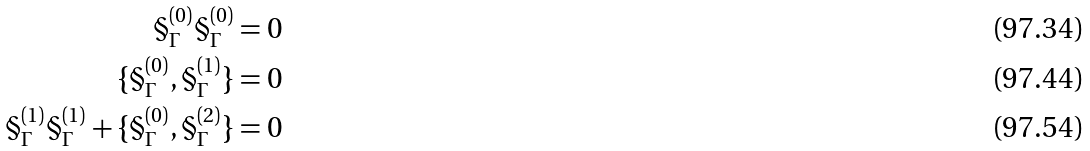Convert formula to latex. <formula><loc_0><loc_0><loc_500><loc_500>\S _ { \Gamma } ^ { ( 0 ) } \S _ { \Gamma } ^ { ( 0 ) } & = 0 \\ \{ \S _ { \Gamma } ^ { ( 0 ) } , \S _ { \Gamma } ^ { ( 1 ) } \} & = 0 \\ \S _ { \Gamma } ^ { ( 1 ) } \S _ { \Gamma } ^ { ( 1 ) } + \{ \S _ { \Gamma } ^ { ( 0 ) } , \S _ { \Gamma } ^ { ( 2 ) } \} & = 0</formula> 